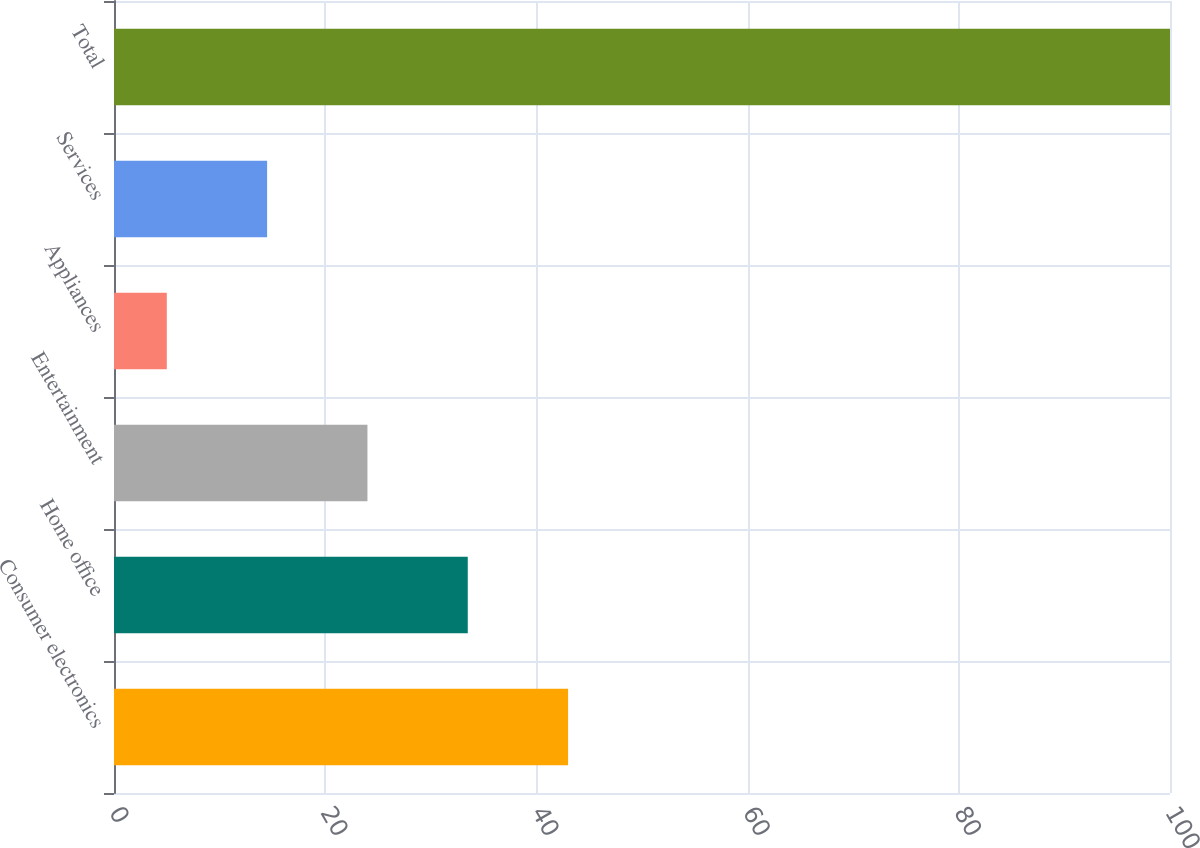Convert chart. <chart><loc_0><loc_0><loc_500><loc_500><bar_chart><fcel>Consumer electronics<fcel>Home office<fcel>Entertainment<fcel>Appliances<fcel>Services<fcel>Total<nl><fcel>43<fcel>33.5<fcel>24<fcel>5<fcel>14.5<fcel>100<nl></chart> 